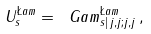Convert formula to latex. <formula><loc_0><loc_0><loc_500><loc_500>U _ { s } ^ { \L a m } = \ G a m ^ { \L a m } _ { s | \, j , j ; j , j } \, ,</formula> 